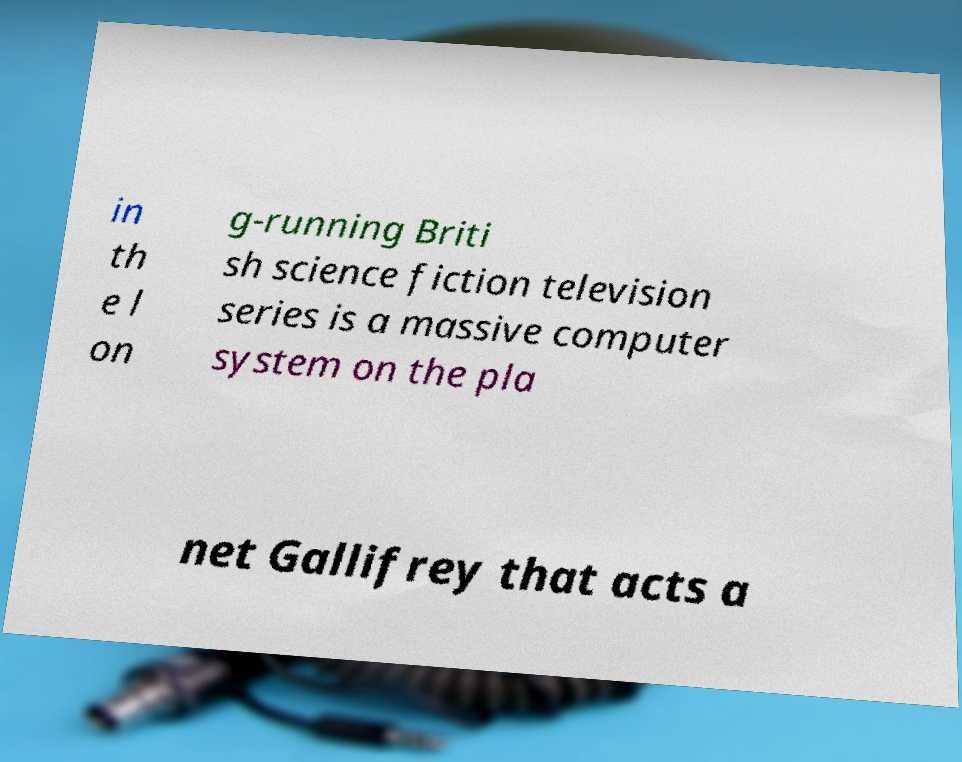For documentation purposes, I need the text within this image transcribed. Could you provide that? in th e l on g-running Briti sh science fiction television series is a massive computer system on the pla net Gallifrey that acts a 